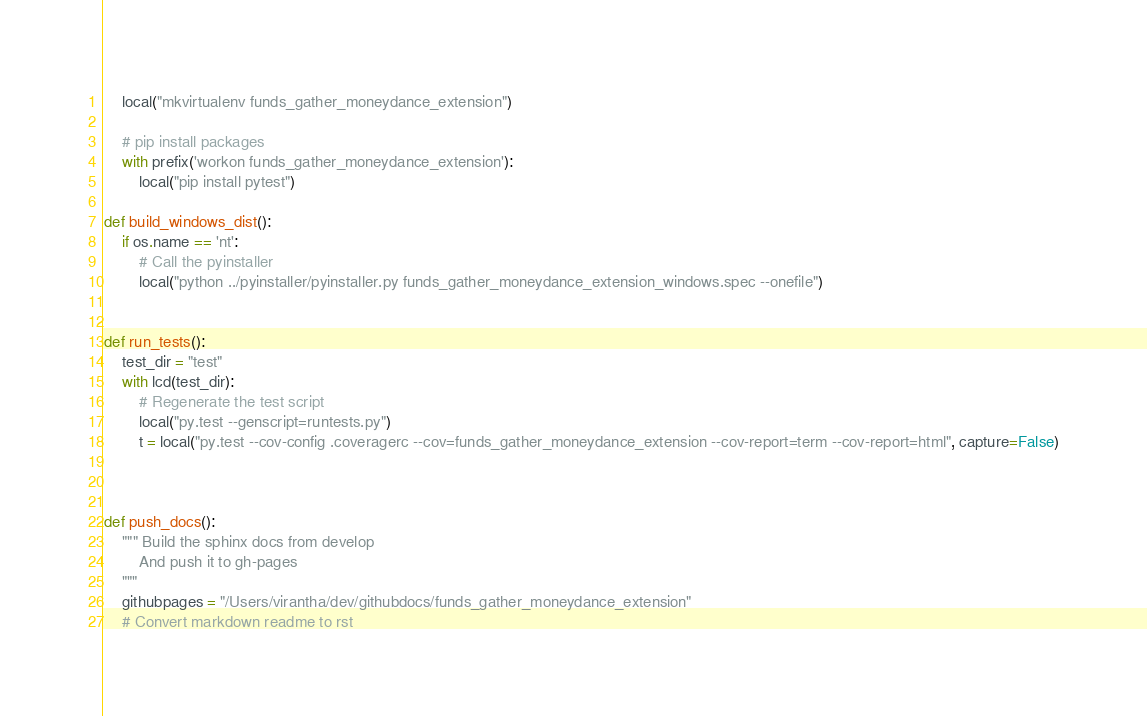Convert code to text. <code><loc_0><loc_0><loc_500><loc_500><_Python_>    local("mkvirtualenv funds_gather_moneydance_extension")

    # pip install packages
    with prefix('workon funds_gather_moneydance_extension'):
        local("pip install pytest")

def build_windows_dist():
    if os.name == 'nt':
        # Call the pyinstaller
        local("python ../pyinstaller/pyinstaller.py funds_gather_moneydance_extension_windows.spec --onefile")


def run_tests():
    test_dir = "test"
    with lcd(test_dir):
        # Regenerate the test script
        local("py.test --genscript=runtests.py")
        t = local("py.test --cov-config .coveragerc --cov=funds_gather_moneydance_extension --cov-report=term --cov-report=html", capture=False)



def push_docs():
    """ Build the sphinx docs from develop
        And push it to gh-pages
    """
    githubpages = "/Users/virantha/dev/githubdocs/funds_gather_moneydance_extension"
    # Convert markdown readme to rst</code> 